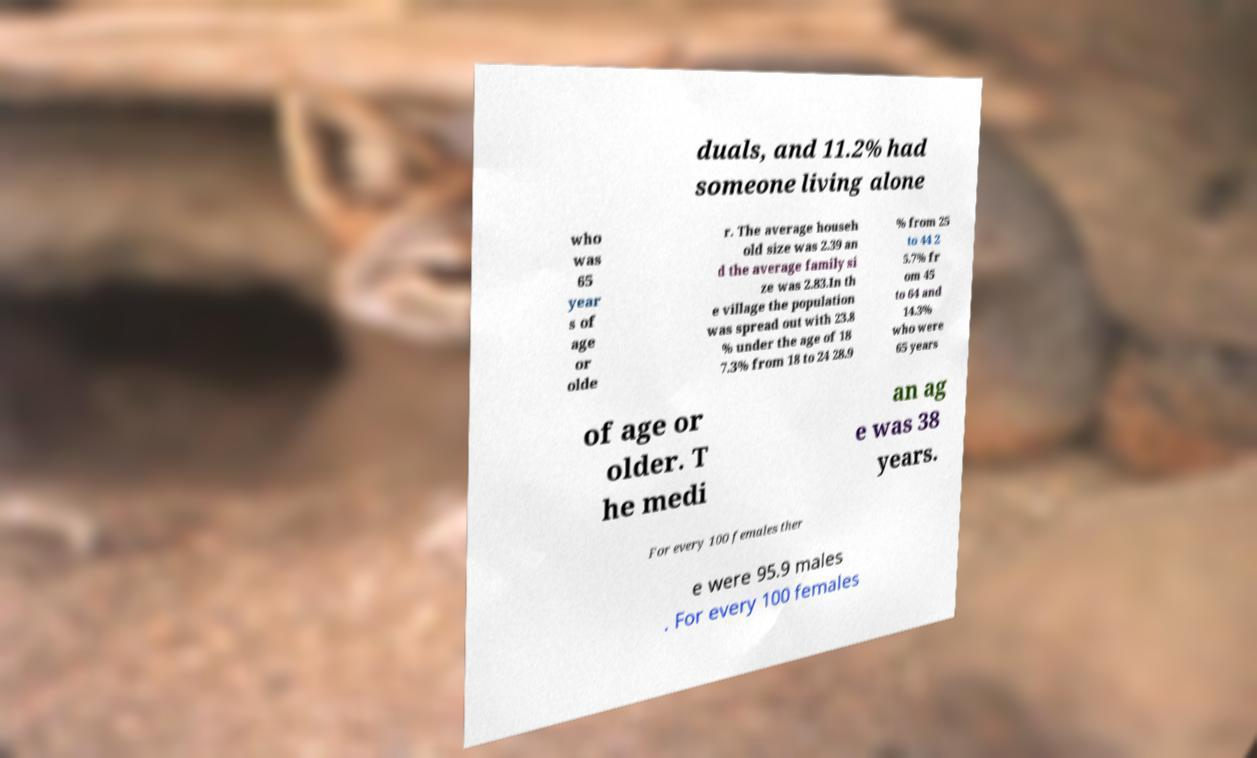For documentation purposes, I need the text within this image transcribed. Could you provide that? duals, and 11.2% had someone living alone who was 65 year s of age or olde r. The average househ old size was 2.39 an d the average family si ze was 2.83.In th e village the population was spread out with 23.8 % under the age of 18 7.3% from 18 to 24 28.9 % from 25 to 44 2 5.7% fr om 45 to 64 and 14.3% who were 65 years of age or older. T he medi an ag e was 38 years. For every 100 females ther e were 95.9 males . For every 100 females 